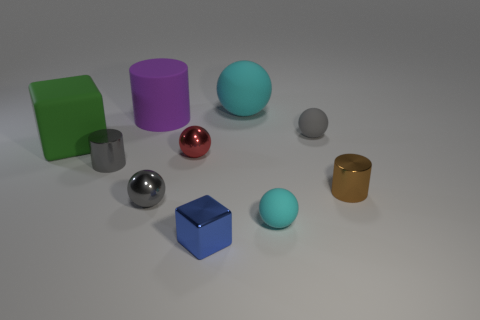Subtract all big cylinders. How many cylinders are left? 2 Subtract all blue cubes. How many cubes are left? 1 Subtract 2 cylinders. How many cylinders are left? 1 Subtract all red shiny objects. Subtract all matte blocks. How many objects are left? 8 Add 1 small red metal things. How many small red metal things are left? 2 Add 2 large cubes. How many large cubes exist? 3 Subtract 0 brown spheres. How many objects are left? 10 Subtract all cylinders. How many objects are left? 7 Subtract all brown spheres. Subtract all red cubes. How many spheres are left? 5 Subtract all blue cylinders. How many gray balls are left? 2 